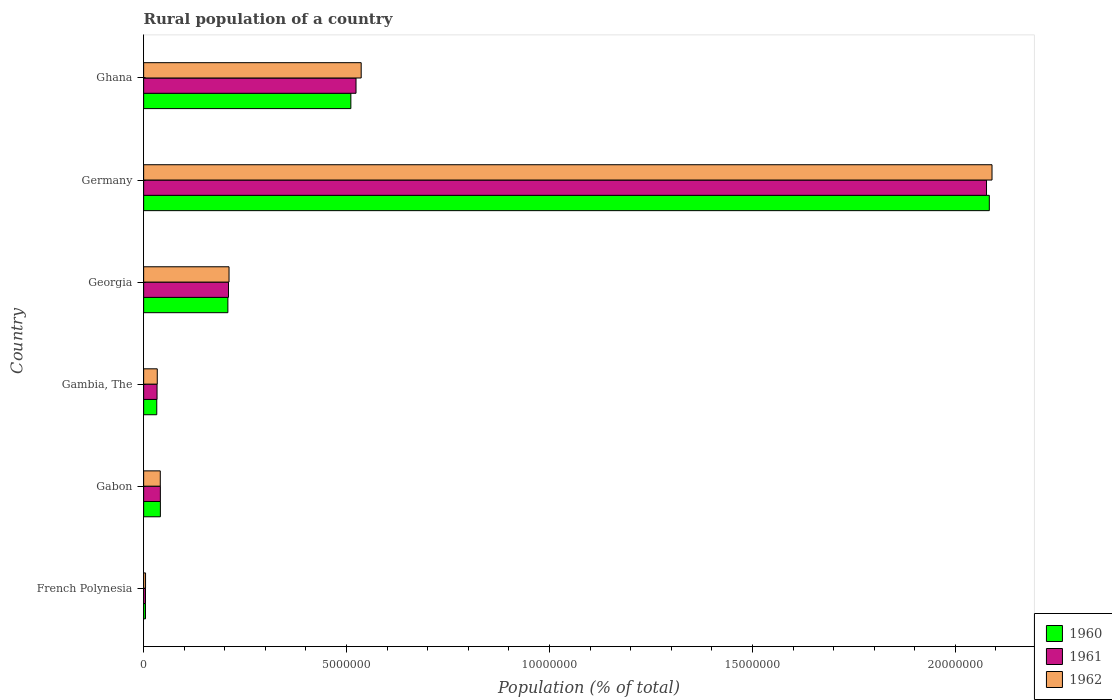How many different coloured bars are there?
Your answer should be very brief. 3. How many groups of bars are there?
Your answer should be compact. 6. How many bars are there on the 5th tick from the top?
Keep it short and to the point. 3. How many bars are there on the 3rd tick from the bottom?
Make the answer very short. 3. What is the label of the 5th group of bars from the top?
Ensure brevity in your answer.  Gabon. In how many cases, is the number of bars for a given country not equal to the number of legend labels?
Provide a short and direct response. 0. What is the rural population in 1960 in French Polynesia?
Provide a succinct answer. 4.51e+04. Across all countries, what is the maximum rural population in 1960?
Your response must be concise. 2.08e+07. Across all countries, what is the minimum rural population in 1962?
Provide a short and direct response. 4.67e+04. In which country was the rural population in 1961 maximum?
Offer a terse response. Germany. In which country was the rural population in 1961 minimum?
Provide a succinct answer. French Polynesia. What is the total rural population in 1961 in the graph?
Offer a terse response. 2.89e+07. What is the difference between the rural population in 1962 in Germany and that in Ghana?
Offer a very short reply. 1.55e+07. What is the difference between the rural population in 1961 in Ghana and the rural population in 1960 in French Polynesia?
Give a very brief answer. 5.19e+06. What is the average rural population in 1960 per country?
Ensure brevity in your answer.  4.80e+06. What is the difference between the rural population in 1962 and rural population in 1961 in Georgia?
Give a very brief answer. 1.35e+04. What is the ratio of the rural population in 1960 in Gabon to that in Gambia, The?
Provide a succinct answer. 1.28. Is the rural population in 1962 in Georgia less than that in Ghana?
Give a very brief answer. Yes. What is the difference between the highest and the second highest rural population in 1960?
Offer a terse response. 1.57e+07. What is the difference between the highest and the lowest rural population in 1960?
Provide a succinct answer. 2.08e+07. In how many countries, is the rural population in 1961 greater than the average rural population in 1961 taken over all countries?
Offer a terse response. 2. How many bars are there?
Your answer should be very brief. 18. Are all the bars in the graph horizontal?
Give a very brief answer. Yes. How many countries are there in the graph?
Give a very brief answer. 6. What is the difference between two consecutive major ticks on the X-axis?
Provide a short and direct response. 5.00e+06. Are the values on the major ticks of X-axis written in scientific E-notation?
Offer a terse response. No. Where does the legend appear in the graph?
Ensure brevity in your answer.  Bottom right. How many legend labels are there?
Make the answer very short. 3. What is the title of the graph?
Give a very brief answer. Rural population of a country. Does "1978" appear as one of the legend labels in the graph?
Make the answer very short. No. What is the label or title of the X-axis?
Provide a succinct answer. Population (% of total). What is the label or title of the Y-axis?
Offer a terse response. Country. What is the Population (% of total) in 1960 in French Polynesia?
Offer a terse response. 4.51e+04. What is the Population (% of total) in 1961 in French Polynesia?
Your answer should be compact. 4.58e+04. What is the Population (% of total) in 1962 in French Polynesia?
Offer a terse response. 4.67e+04. What is the Population (% of total) in 1960 in Gabon?
Ensure brevity in your answer.  4.12e+05. What is the Population (% of total) of 1961 in Gabon?
Your answer should be very brief. 4.12e+05. What is the Population (% of total) in 1962 in Gabon?
Your answer should be compact. 4.10e+05. What is the Population (% of total) in 1960 in Gambia, The?
Your answer should be very brief. 3.23e+05. What is the Population (% of total) of 1961 in Gambia, The?
Make the answer very short. 3.30e+05. What is the Population (% of total) in 1962 in Gambia, The?
Offer a terse response. 3.35e+05. What is the Population (% of total) in 1960 in Georgia?
Keep it short and to the point. 2.08e+06. What is the Population (% of total) of 1961 in Georgia?
Offer a terse response. 2.09e+06. What is the Population (% of total) of 1962 in Georgia?
Provide a short and direct response. 2.10e+06. What is the Population (% of total) in 1960 in Germany?
Make the answer very short. 2.08e+07. What is the Population (% of total) in 1961 in Germany?
Give a very brief answer. 2.08e+07. What is the Population (% of total) in 1962 in Germany?
Your answer should be compact. 2.09e+07. What is the Population (% of total) of 1960 in Ghana?
Offer a terse response. 5.11e+06. What is the Population (% of total) of 1961 in Ghana?
Give a very brief answer. 5.23e+06. What is the Population (% of total) of 1962 in Ghana?
Your response must be concise. 5.36e+06. Across all countries, what is the maximum Population (% of total) of 1960?
Make the answer very short. 2.08e+07. Across all countries, what is the maximum Population (% of total) of 1961?
Offer a very short reply. 2.08e+07. Across all countries, what is the maximum Population (% of total) in 1962?
Your answer should be compact. 2.09e+07. Across all countries, what is the minimum Population (% of total) of 1960?
Make the answer very short. 4.51e+04. Across all countries, what is the minimum Population (% of total) in 1961?
Provide a succinct answer. 4.58e+04. Across all countries, what is the minimum Population (% of total) in 1962?
Make the answer very short. 4.67e+04. What is the total Population (% of total) of 1960 in the graph?
Provide a succinct answer. 2.88e+07. What is the total Population (% of total) in 1961 in the graph?
Ensure brevity in your answer.  2.89e+07. What is the total Population (% of total) in 1962 in the graph?
Ensure brevity in your answer.  2.92e+07. What is the difference between the Population (% of total) in 1960 in French Polynesia and that in Gabon?
Make the answer very short. -3.67e+05. What is the difference between the Population (% of total) in 1961 in French Polynesia and that in Gabon?
Keep it short and to the point. -3.66e+05. What is the difference between the Population (% of total) of 1962 in French Polynesia and that in Gabon?
Provide a short and direct response. -3.63e+05. What is the difference between the Population (% of total) of 1960 in French Polynesia and that in Gambia, The?
Your answer should be compact. -2.78e+05. What is the difference between the Population (% of total) in 1961 in French Polynesia and that in Gambia, The?
Ensure brevity in your answer.  -2.84e+05. What is the difference between the Population (% of total) of 1962 in French Polynesia and that in Gambia, The?
Make the answer very short. -2.89e+05. What is the difference between the Population (% of total) of 1960 in French Polynesia and that in Georgia?
Your answer should be compact. -2.03e+06. What is the difference between the Population (% of total) in 1961 in French Polynesia and that in Georgia?
Your answer should be very brief. -2.04e+06. What is the difference between the Population (% of total) in 1962 in French Polynesia and that in Georgia?
Give a very brief answer. -2.06e+06. What is the difference between the Population (% of total) of 1960 in French Polynesia and that in Germany?
Ensure brevity in your answer.  -2.08e+07. What is the difference between the Population (% of total) in 1961 in French Polynesia and that in Germany?
Your answer should be very brief. -2.07e+07. What is the difference between the Population (% of total) in 1962 in French Polynesia and that in Germany?
Offer a very short reply. -2.09e+07. What is the difference between the Population (% of total) in 1960 in French Polynesia and that in Ghana?
Give a very brief answer. -5.06e+06. What is the difference between the Population (% of total) of 1961 in French Polynesia and that in Ghana?
Make the answer very short. -5.19e+06. What is the difference between the Population (% of total) in 1962 in French Polynesia and that in Ghana?
Your answer should be compact. -5.31e+06. What is the difference between the Population (% of total) of 1960 in Gabon and that in Gambia, The?
Offer a terse response. 8.90e+04. What is the difference between the Population (% of total) of 1961 in Gabon and that in Gambia, The?
Ensure brevity in your answer.  8.15e+04. What is the difference between the Population (% of total) in 1962 in Gabon and that in Gambia, The?
Keep it short and to the point. 7.45e+04. What is the difference between the Population (% of total) of 1960 in Gabon and that in Georgia?
Make the answer very short. -1.66e+06. What is the difference between the Population (% of total) of 1961 in Gabon and that in Georgia?
Provide a succinct answer. -1.68e+06. What is the difference between the Population (% of total) of 1962 in Gabon and that in Georgia?
Provide a short and direct response. -1.69e+06. What is the difference between the Population (% of total) of 1960 in Gabon and that in Germany?
Ensure brevity in your answer.  -2.04e+07. What is the difference between the Population (% of total) of 1961 in Gabon and that in Germany?
Your response must be concise. -2.04e+07. What is the difference between the Population (% of total) in 1962 in Gabon and that in Germany?
Keep it short and to the point. -2.05e+07. What is the difference between the Population (% of total) in 1960 in Gabon and that in Ghana?
Your answer should be very brief. -4.69e+06. What is the difference between the Population (% of total) of 1961 in Gabon and that in Ghana?
Provide a short and direct response. -4.82e+06. What is the difference between the Population (% of total) in 1962 in Gabon and that in Ghana?
Your answer should be compact. -4.95e+06. What is the difference between the Population (% of total) of 1960 in Gambia, The and that in Georgia?
Your response must be concise. -1.75e+06. What is the difference between the Population (% of total) of 1961 in Gambia, The and that in Georgia?
Ensure brevity in your answer.  -1.76e+06. What is the difference between the Population (% of total) of 1962 in Gambia, The and that in Georgia?
Your answer should be very brief. -1.77e+06. What is the difference between the Population (% of total) in 1960 in Gambia, The and that in Germany?
Your answer should be very brief. -2.05e+07. What is the difference between the Population (% of total) in 1961 in Gambia, The and that in Germany?
Give a very brief answer. -2.04e+07. What is the difference between the Population (% of total) in 1962 in Gambia, The and that in Germany?
Your answer should be very brief. -2.06e+07. What is the difference between the Population (% of total) of 1960 in Gambia, The and that in Ghana?
Offer a terse response. -4.78e+06. What is the difference between the Population (% of total) of 1961 in Gambia, The and that in Ghana?
Provide a short and direct response. -4.90e+06. What is the difference between the Population (% of total) in 1962 in Gambia, The and that in Ghana?
Your response must be concise. -5.02e+06. What is the difference between the Population (% of total) of 1960 in Georgia and that in Germany?
Your response must be concise. -1.88e+07. What is the difference between the Population (% of total) of 1961 in Georgia and that in Germany?
Ensure brevity in your answer.  -1.87e+07. What is the difference between the Population (% of total) of 1962 in Georgia and that in Germany?
Offer a very short reply. -1.88e+07. What is the difference between the Population (% of total) in 1960 in Georgia and that in Ghana?
Provide a succinct answer. -3.03e+06. What is the difference between the Population (% of total) of 1961 in Georgia and that in Ghana?
Keep it short and to the point. -3.14e+06. What is the difference between the Population (% of total) of 1962 in Georgia and that in Ghana?
Your answer should be very brief. -3.26e+06. What is the difference between the Population (% of total) of 1960 in Germany and that in Ghana?
Offer a very short reply. 1.57e+07. What is the difference between the Population (% of total) of 1961 in Germany and that in Ghana?
Ensure brevity in your answer.  1.55e+07. What is the difference between the Population (% of total) of 1962 in Germany and that in Ghana?
Provide a short and direct response. 1.55e+07. What is the difference between the Population (% of total) of 1960 in French Polynesia and the Population (% of total) of 1961 in Gabon?
Offer a very short reply. -3.67e+05. What is the difference between the Population (% of total) of 1960 in French Polynesia and the Population (% of total) of 1962 in Gabon?
Your answer should be compact. -3.65e+05. What is the difference between the Population (% of total) in 1961 in French Polynesia and the Population (% of total) in 1962 in Gabon?
Ensure brevity in your answer.  -3.64e+05. What is the difference between the Population (% of total) of 1960 in French Polynesia and the Population (% of total) of 1961 in Gambia, The?
Your answer should be very brief. -2.85e+05. What is the difference between the Population (% of total) in 1960 in French Polynesia and the Population (% of total) in 1962 in Gambia, The?
Give a very brief answer. -2.90e+05. What is the difference between the Population (% of total) of 1961 in French Polynesia and the Population (% of total) of 1962 in Gambia, The?
Give a very brief answer. -2.90e+05. What is the difference between the Population (% of total) in 1960 in French Polynesia and the Population (% of total) in 1961 in Georgia?
Offer a terse response. -2.05e+06. What is the difference between the Population (% of total) of 1960 in French Polynesia and the Population (% of total) of 1962 in Georgia?
Offer a terse response. -2.06e+06. What is the difference between the Population (% of total) of 1961 in French Polynesia and the Population (% of total) of 1962 in Georgia?
Make the answer very short. -2.06e+06. What is the difference between the Population (% of total) of 1960 in French Polynesia and the Population (% of total) of 1961 in Germany?
Make the answer very short. -2.07e+07. What is the difference between the Population (% of total) of 1960 in French Polynesia and the Population (% of total) of 1962 in Germany?
Make the answer very short. -2.09e+07. What is the difference between the Population (% of total) of 1961 in French Polynesia and the Population (% of total) of 1962 in Germany?
Give a very brief answer. -2.09e+07. What is the difference between the Population (% of total) of 1960 in French Polynesia and the Population (% of total) of 1961 in Ghana?
Keep it short and to the point. -5.19e+06. What is the difference between the Population (% of total) in 1960 in French Polynesia and the Population (% of total) in 1962 in Ghana?
Keep it short and to the point. -5.31e+06. What is the difference between the Population (% of total) in 1961 in French Polynesia and the Population (% of total) in 1962 in Ghana?
Your answer should be very brief. -5.31e+06. What is the difference between the Population (% of total) in 1960 in Gabon and the Population (% of total) in 1961 in Gambia, The?
Keep it short and to the point. 8.21e+04. What is the difference between the Population (% of total) of 1960 in Gabon and the Population (% of total) of 1962 in Gambia, The?
Make the answer very short. 7.69e+04. What is the difference between the Population (% of total) of 1961 in Gabon and the Population (% of total) of 1962 in Gambia, The?
Offer a terse response. 7.63e+04. What is the difference between the Population (% of total) in 1960 in Gabon and the Population (% of total) in 1961 in Georgia?
Provide a succinct answer. -1.68e+06. What is the difference between the Population (% of total) in 1960 in Gabon and the Population (% of total) in 1962 in Georgia?
Offer a terse response. -1.69e+06. What is the difference between the Population (% of total) of 1961 in Gabon and the Population (% of total) of 1962 in Georgia?
Give a very brief answer. -1.69e+06. What is the difference between the Population (% of total) of 1960 in Gabon and the Population (% of total) of 1961 in Germany?
Keep it short and to the point. -2.04e+07. What is the difference between the Population (% of total) of 1960 in Gabon and the Population (% of total) of 1962 in Germany?
Offer a very short reply. -2.05e+07. What is the difference between the Population (% of total) of 1961 in Gabon and the Population (% of total) of 1962 in Germany?
Your answer should be compact. -2.05e+07. What is the difference between the Population (% of total) of 1960 in Gabon and the Population (% of total) of 1961 in Ghana?
Provide a short and direct response. -4.82e+06. What is the difference between the Population (% of total) of 1960 in Gabon and the Population (% of total) of 1962 in Ghana?
Make the answer very short. -4.95e+06. What is the difference between the Population (% of total) of 1961 in Gabon and the Population (% of total) of 1962 in Ghana?
Provide a short and direct response. -4.95e+06. What is the difference between the Population (% of total) of 1960 in Gambia, The and the Population (% of total) of 1961 in Georgia?
Offer a very short reply. -1.77e+06. What is the difference between the Population (% of total) in 1960 in Gambia, The and the Population (% of total) in 1962 in Georgia?
Your response must be concise. -1.78e+06. What is the difference between the Population (% of total) in 1961 in Gambia, The and the Population (% of total) in 1962 in Georgia?
Offer a very short reply. -1.77e+06. What is the difference between the Population (% of total) of 1960 in Gambia, The and the Population (% of total) of 1961 in Germany?
Offer a very short reply. -2.04e+07. What is the difference between the Population (% of total) of 1960 in Gambia, The and the Population (% of total) of 1962 in Germany?
Keep it short and to the point. -2.06e+07. What is the difference between the Population (% of total) of 1961 in Gambia, The and the Population (% of total) of 1962 in Germany?
Provide a succinct answer. -2.06e+07. What is the difference between the Population (% of total) in 1960 in Gambia, The and the Population (% of total) in 1961 in Ghana?
Ensure brevity in your answer.  -4.91e+06. What is the difference between the Population (% of total) in 1960 in Gambia, The and the Population (% of total) in 1962 in Ghana?
Your answer should be compact. -5.04e+06. What is the difference between the Population (% of total) of 1961 in Gambia, The and the Population (% of total) of 1962 in Ghana?
Provide a succinct answer. -5.03e+06. What is the difference between the Population (% of total) of 1960 in Georgia and the Population (% of total) of 1961 in Germany?
Your answer should be very brief. -1.87e+07. What is the difference between the Population (% of total) of 1960 in Georgia and the Population (% of total) of 1962 in Germany?
Offer a terse response. -1.88e+07. What is the difference between the Population (% of total) in 1961 in Georgia and the Population (% of total) in 1962 in Germany?
Your answer should be compact. -1.88e+07. What is the difference between the Population (% of total) in 1960 in Georgia and the Population (% of total) in 1961 in Ghana?
Offer a very short reply. -3.16e+06. What is the difference between the Population (% of total) in 1960 in Georgia and the Population (% of total) in 1962 in Ghana?
Keep it short and to the point. -3.28e+06. What is the difference between the Population (% of total) of 1961 in Georgia and the Population (% of total) of 1962 in Ghana?
Provide a succinct answer. -3.27e+06. What is the difference between the Population (% of total) in 1960 in Germany and the Population (% of total) in 1961 in Ghana?
Offer a terse response. 1.56e+07. What is the difference between the Population (% of total) of 1960 in Germany and the Population (% of total) of 1962 in Ghana?
Ensure brevity in your answer.  1.55e+07. What is the difference between the Population (% of total) in 1961 in Germany and the Population (% of total) in 1962 in Ghana?
Your response must be concise. 1.54e+07. What is the average Population (% of total) of 1960 per country?
Provide a short and direct response. 4.80e+06. What is the average Population (% of total) in 1961 per country?
Your answer should be compact. 4.81e+06. What is the average Population (% of total) of 1962 per country?
Your response must be concise. 4.86e+06. What is the difference between the Population (% of total) in 1960 and Population (% of total) in 1961 in French Polynesia?
Make the answer very short. -758. What is the difference between the Population (% of total) in 1960 and Population (% of total) in 1962 in French Polynesia?
Give a very brief answer. -1643. What is the difference between the Population (% of total) of 1961 and Population (% of total) of 1962 in French Polynesia?
Ensure brevity in your answer.  -885. What is the difference between the Population (% of total) of 1960 and Population (% of total) of 1961 in Gabon?
Provide a succinct answer. 581. What is the difference between the Population (% of total) of 1960 and Population (% of total) of 1962 in Gabon?
Provide a succinct answer. 2425. What is the difference between the Population (% of total) in 1961 and Population (% of total) in 1962 in Gabon?
Your answer should be compact. 1844. What is the difference between the Population (% of total) of 1960 and Population (% of total) of 1961 in Gambia, The?
Offer a terse response. -6978. What is the difference between the Population (% of total) of 1960 and Population (% of total) of 1962 in Gambia, The?
Make the answer very short. -1.21e+04. What is the difference between the Population (% of total) of 1961 and Population (% of total) of 1962 in Gambia, The?
Provide a short and direct response. -5169. What is the difference between the Population (% of total) in 1960 and Population (% of total) in 1961 in Georgia?
Offer a very short reply. -1.49e+04. What is the difference between the Population (% of total) of 1960 and Population (% of total) of 1962 in Georgia?
Your response must be concise. -2.84e+04. What is the difference between the Population (% of total) of 1961 and Population (% of total) of 1962 in Georgia?
Make the answer very short. -1.35e+04. What is the difference between the Population (% of total) of 1960 and Population (% of total) of 1961 in Germany?
Provide a short and direct response. 6.86e+04. What is the difference between the Population (% of total) of 1960 and Population (% of total) of 1962 in Germany?
Make the answer very short. -6.67e+04. What is the difference between the Population (% of total) in 1961 and Population (% of total) in 1962 in Germany?
Give a very brief answer. -1.35e+05. What is the difference between the Population (% of total) of 1960 and Population (% of total) of 1961 in Ghana?
Your answer should be compact. -1.27e+05. What is the difference between the Population (% of total) of 1960 and Population (% of total) of 1962 in Ghana?
Your answer should be compact. -2.55e+05. What is the difference between the Population (% of total) in 1961 and Population (% of total) in 1962 in Ghana?
Your response must be concise. -1.27e+05. What is the ratio of the Population (% of total) in 1960 in French Polynesia to that in Gabon?
Give a very brief answer. 0.11. What is the ratio of the Population (% of total) in 1961 in French Polynesia to that in Gabon?
Ensure brevity in your answer.  0.11. What is the ratio of the Population (% of total) in 1962 in French Polynesia to that in Gabon?
Your response must be concise. 0.11. What is the ratio of the Population (% of total) of 1960 in French Polynesia to that in Gambia, The?
Provide a succinct answer. 0.14. What is the ratio of the Population (% of total) in 1961 in French Polynesia to that in Gambia, The?
Ensure brevity in your answer.  0.14. What is the ratio of the Population (% of total) of 1962 in French Polynesia to that in Gambia, The?
Give a very brief answer. 0.14. What is the ratio of the Population (% of total) of 1960 in French Polynesia to that in Georgia?
Ensure brevity in your answer.  0.02. What is the ratio of the Population (% of total) of 1961 in French Polynesia to that in Georgia?
Give a very brief answer. 0.02. What is the ratio of the Population (% of total) in 1962 in French Polynesia to that in Georgia?
Give a very brief answer. 0.02. What is the ratio of the Population (% of total) in 1960 in French Polynesia to that in Germany?
Your response must be concise. 0. What is the ratio of the Population (% of total) in 1961 in French Polynesia to that in Germany?
Your answer should be compact. 0. What is the ratio of the Population (% of total) in 1962 in French Polynesia to that in Germany?
Your response must be concise. 0. What is the ratio of the Population (% of total) in 1960 in French Polynesia to that in Ghana?
Offer a very short reply. 0.01. What is the ratio of the Population (% of total) in 1961 in French Polynesia to that in Ghana?
Your answer should be compact. 0.01. What is the ratio of the Population (% of total) of 1962 in French Polynesia to that in Ghana?
Ensure brevity in your answer.  0.01. What is the ratio of the Population (% of total) in 1960 in Gabon to that in Gambia, The?
Offer a very short reply. 1.28. What is the ratio of the Population (% of total) in 1961 in Gabon to that in Gambia, The?
Keep it short and to the point. 1.25. What is the ratio of the Population (% of total) of 1962 in Gabon to that in Gambia, The?
Your response must be concise. 1.22. What is the ratio of the Population (% of total) in 1960 in Gabon to that in Georgia?
Keep it short and to the point. 0.2. What is the ratio of the Population (% of total) of 1961 in Gabon to that in Georgia?
Make the answer very short. 0.2. What is the ratio of the Population (% of total) of 1962 in Gabon to that in Georgia?
Your answer should be very brief. 0.19. What is the ratio of the Population (% of total) of 1960 in Gabon to that in Germany?
Ensure brevity in your answer.  0.02. What is the ratio of the Population (% of total) of 1961 in Gabon to that in Germany?
Ensure brevity in your answer.  0.02. What is the ratio of the Population (% of total) of 1962 in Gabon to that in Germany?
Your response must be concise. 0.02. What is the ratio of the Population (% of total) in 1960 in Gabon to that in Ghana?
Offer a terse response. 0.08. What is the ratio of the Population (% of total) in 1961 in Gabon to that in Ghana?
Your answer should be compact. 0.08. What is the ratio of the Population (% of total) of 1962 in Gabon to that in Ghana?
Your response must be concise. 0.08. What is the ratio of the Population (% of total) of 1960 in Gambia, The to that in Georgia?
Give a very brief answer. 0.16. What is the ratio of the Population (% of total) of 1961 in Gambia, The to that in Georgia?
Your answer should be compact. 0.16. What is the ratio of the Population (% of total) in 1962 in Gambia, The to that in Georgia?
Make the answer very short. 0.16. What is the ratio of the Population (% of total) of 1960 in Gambia, The to that in Germany?
Your answer should be compact. 0.02. What is the ratio of the Population (% of total) in 1961 in Gambia, The to that in Germany?
Your answer should be very brief. 0.02. What is the ratio of the Population (% of total) of 1962 in Gambia, The to that in Germany?
Keep it short and to the point. 0.02. What is the ratio of the Population (% of total) of 1960 in Gambia, The to that in Ghana?
Provide a succinct answer. 0.06. What is the ratio of the Population (% of total) in 1961 in Gambia, The to that in Ghana?
Your answer should be compact. 0.06. What is the ratio of the Population (% of total) in 1962 in Gambia, The to that in Ghana?
Provide a succinct answer. 0.06. What is the ratio of the Population (% of total) of 1960 in Georgia to that in Germany?
Offer a terse response. 0.1. What is the ratio of the Population (% of total) of 1961 in Georgia to that in Germany?
Provide a short and direct response. 0.1. What is the ratio of the Population (% of total) of 1962 in Georgia to that in Germany?
Offer a very short reply. 0.1. What is the ratio of the Population (% of total) of 1960 in Georgia to that in Ghana?
Offer a terse response. 0.41. What is the ratio of the Population (% of total) of 1961 in Georgia to that in Ghana?
Offer a very short reply. 0.4. What is the ratio of the Population (% of total) in 1962 in Georgia to that in Ghana?
Your answer should be very brief. 0.39. What is the ratio of the Population (% of total) of 1960 in Germany to that in Ghana?
Make the answer very short. 4.08. What is the ratio of the Population (% of total) in 1961 in Germany to that in Ghana?
Offer a very short reply. 3.97. What is the ratio of the Population (% of total) in 1962 in Germany to that in Ghana?
Provide a succinct answer. 3.9. What is the difference between the highest and the second highest Population (% of total) in 1960?
Your answer should be very brief. 1.57e+07. What is the difference between the highest and the second highest Population (% of total) of 1961?
Keep it short and to the point. 1.55e+07. What is the difference between the highest and the second highest Population (% of total) in 1962?
Your answer should be compact. 1.55e+07. What is the difference between the highest and the lowest Population (% of total) of 1960?
Make the answer very short. 2.08e+07. What is the difference between the highest and the lowest Population (% of total) of 1961?
Ensure brevity in your answer.  2.07e+07. What is the difference between the highest and the lowest Population (% of total) of 1962?
Offer a terse response. 2.09e+07. 